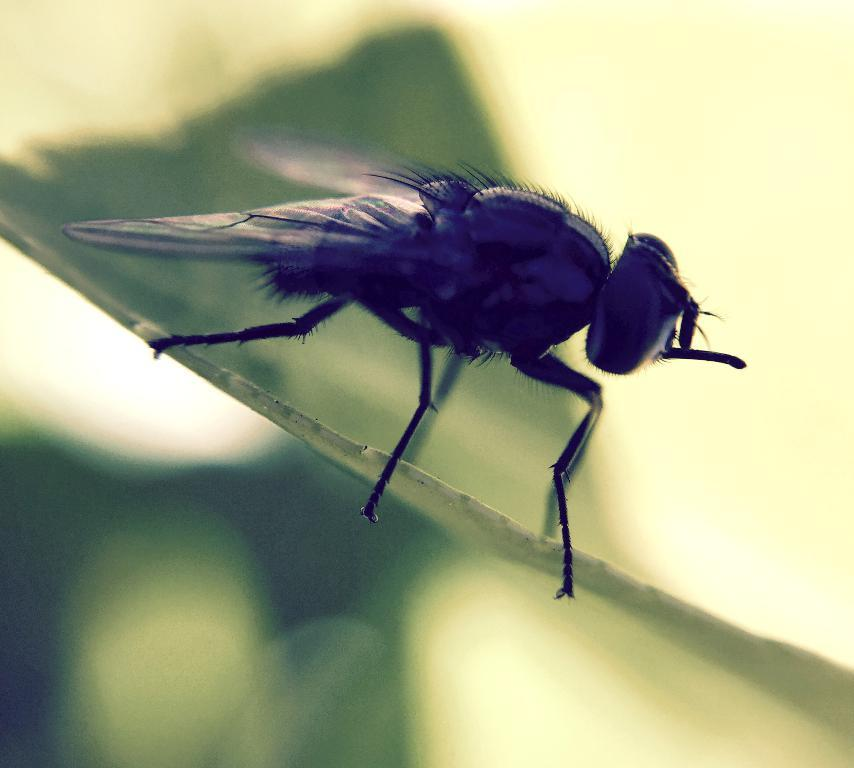What is the main subject of the image? The main subject of the image is a housefly. Where is the housefly located in the image? The housefly is standing on a leaf. Is there a fire visible in the image? No, there is no fire present in the image. What type of smoke can be seen coming from the housefly? There is no smoke associated with the housefly in the image. 